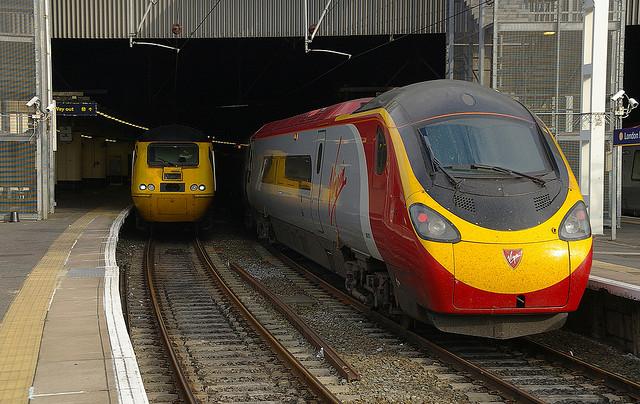How many windshield wipers does the train have?
Concise answer only. 2. How many trains are seen?
Answer briefly. 2. Is there a red and yellow caterpillar on the right?
Concise answer only. No. Is it night time?
Concise answer only. No. 